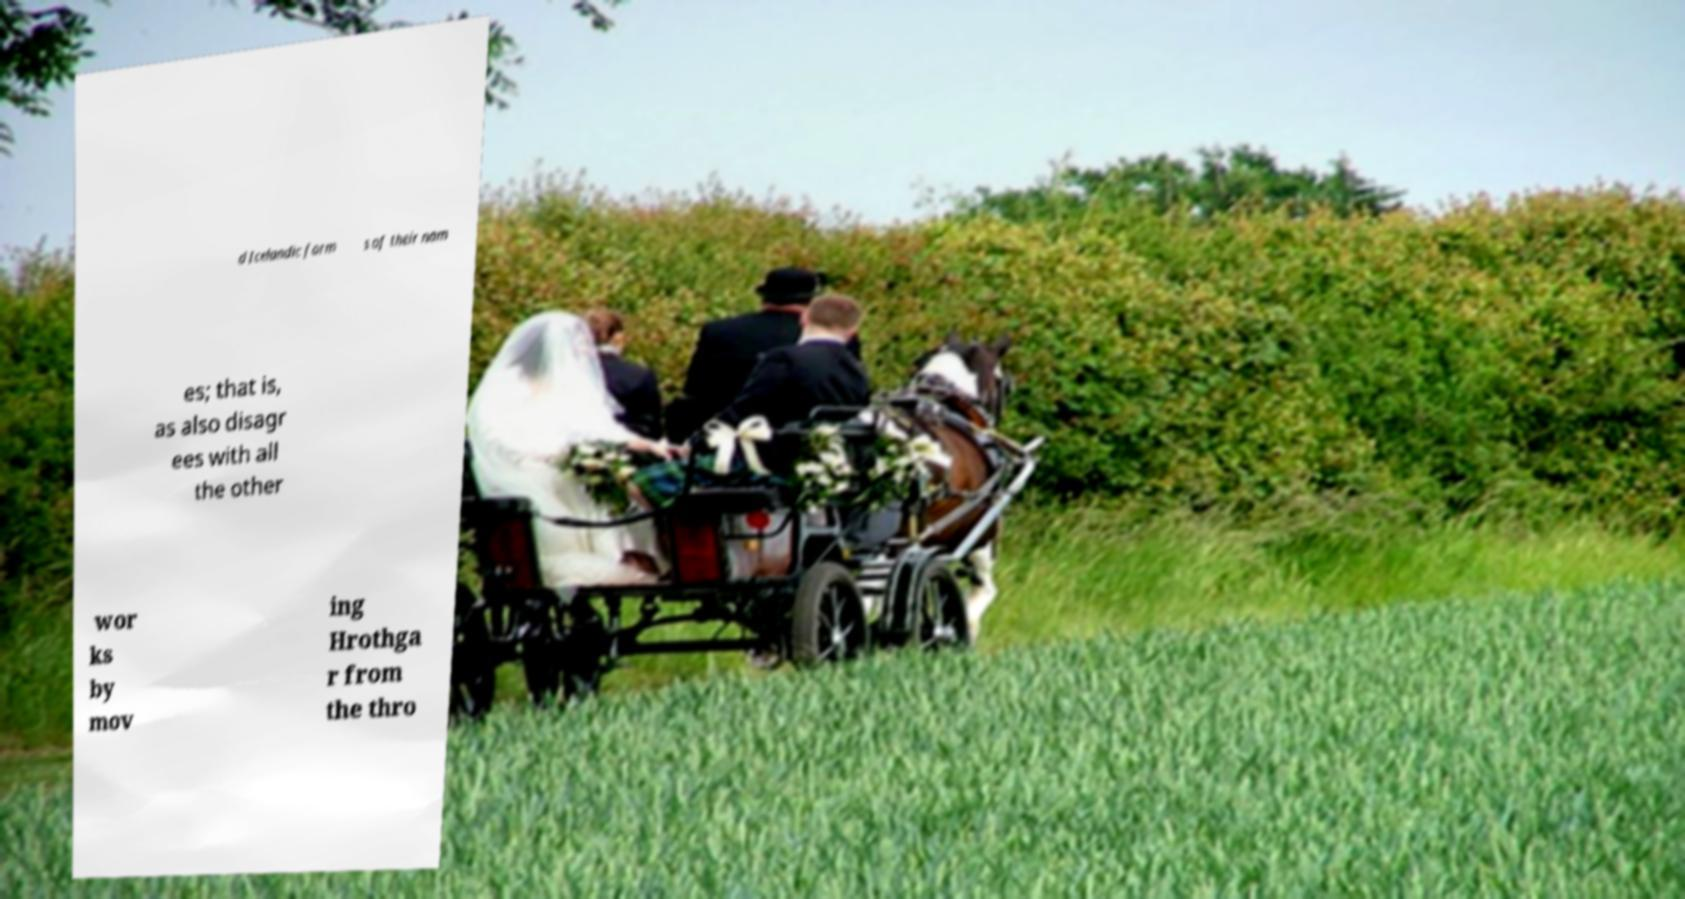Can you read and provide the text displayed in the image?This photo seems to have some interesting text. Can you extract and type it out for me? d Icelandic form s of their nam es; that is, as also disagr ees with all the other wor ks by mov ing Hrothga r from the thro 